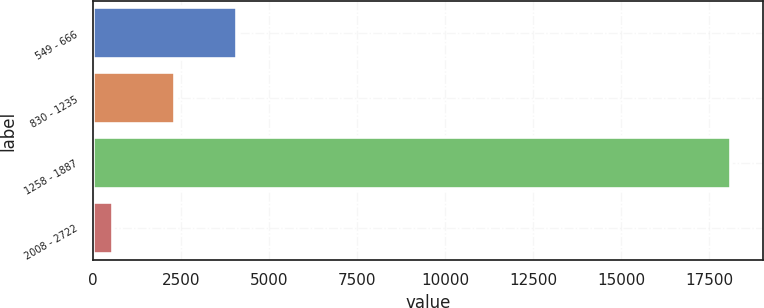Convert chart. <chart><loc_0><loc_0><loc_500><loc_500><bar_chart><fcel>549 - 666<fcel>830 - 1235<fcel>1258 - 1887<fcel>2008 - 2722<nl><fcel>4084.6<fcel>2331.3<fcel>18111<fcel>578<nl></chart> 